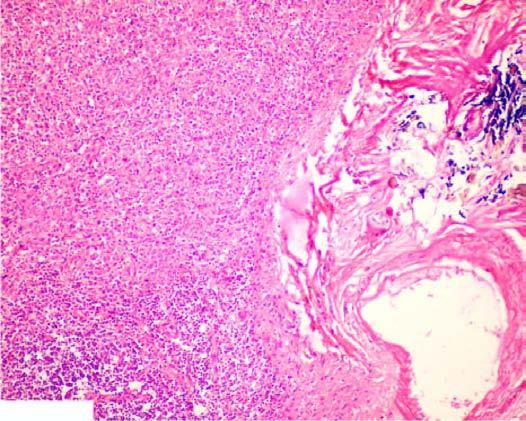what is there increased in the red pulp, capsule and the trabeculae?
Answer the question using a single word or phrase. Fibrosis trabeculae 